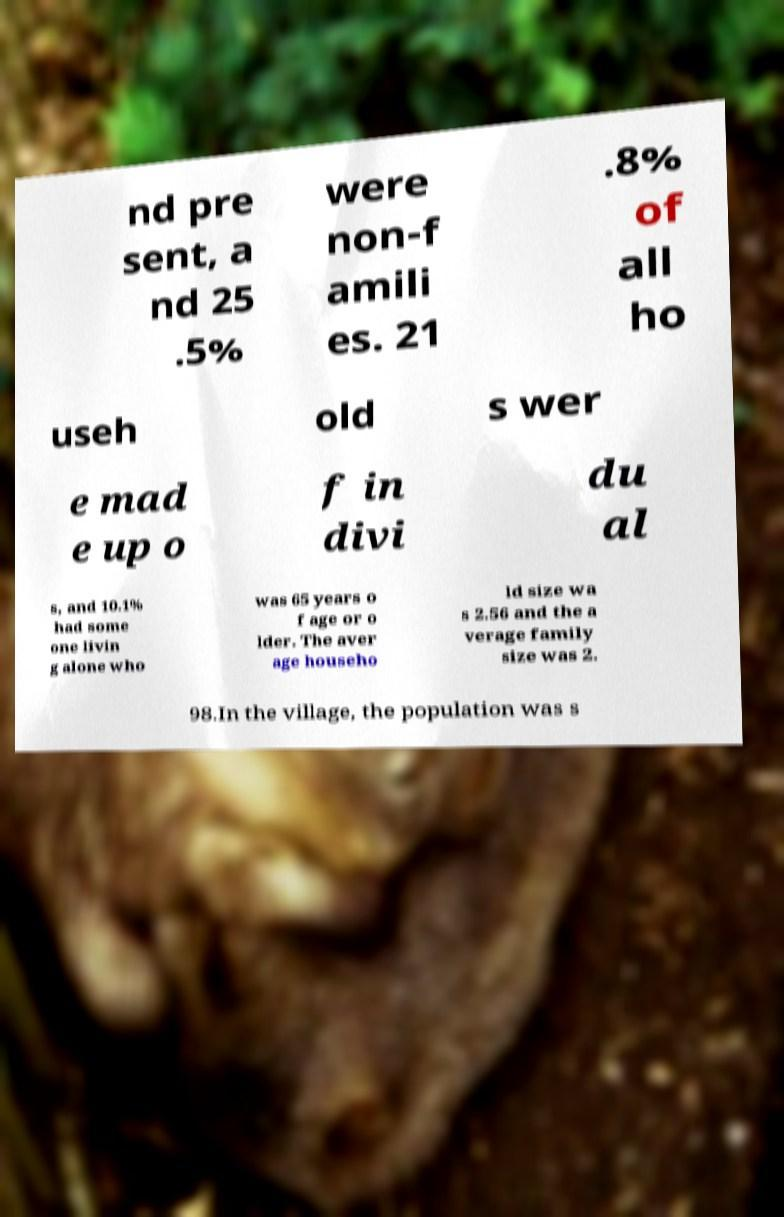Please read and relay the text visible in this image. What does it say? nd pre sent, a nd 25 .5% were non-f amili es. 21 .8% of all ho useh old s wer e mad e up o f in divi du al s, and 10.1% had some one livin g alone who was 65 years o f age or o lder. The aver age househo ld size wa s 2.56 and the a verage family size was 2. 98.In the village, the population was s 